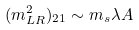<formula> <loc_0><loc_0><loc_500><loc_500>( m ^ { 2 } _ { L R } ) _ { 2 1 } \sim m _ { s } \lambda A</formula> 